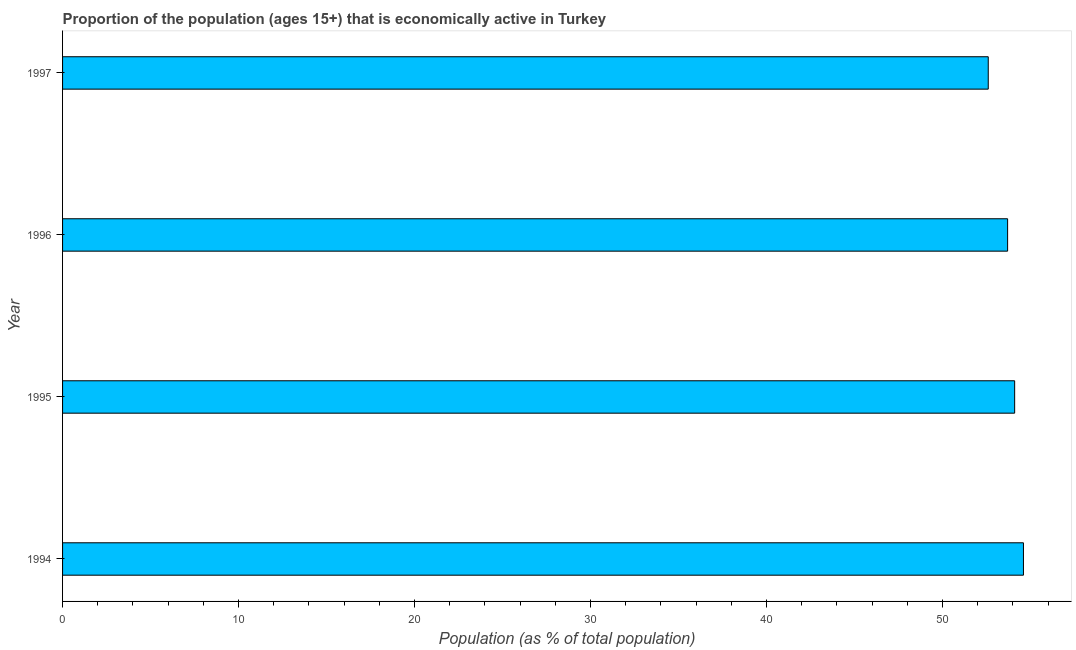What is the title of the graph?
Your answer should be compact. Proportion of the population (ages 15+) that is economically active in Turkey. What is the label or title of the X-axis?
Your response must be concise. Population (as % of total population). What is the label or title of the Y-axis?
Provide a succinct answer. Year. What is the percentage of economically active population in 1995?
Make the answer very short. 54.1. Across all years, what is the maximum percentage of economically active population?
Offer a very short reply. 54.6. Across all years, what is the minimum percentage of economically active population?
Make the answer very short. 52.6. In which year was the percentage of economically active population maximum?
Your answer should be very brief. 1994. What is the sum of the percentage of economically active population?
Give a very brief answer. 215. What is the average percentage of economically active population per year?
Offer a terse response. 53.75. What is the median percentage of economically active population?
Your answer should be compact. 53.9. Do a majority of the years between 1995 and 1996 (inclusive) have percentage of economically active population greater than 52 %?
Keep it short and to the point. Yes. What is the ratio of the percentage of economically active population in 1995 to that in 1997?
Provide a succinct answer. 1.03. Is the percentage of economically active population in 1994 less than that in 1997?
Your response must be concise. No. What is the difference between the highest and the second highest percentage of economically active population?
Offer a very short reply. 0.5. Is the sum of the percentage of economically active population in 1994 and 1996 greater than the maximum percentage of economically active population across all years?
Provide a succinct answer. Yes. What is the difference between the highest and the lowest percentage of economically active population?
Keep it short and to the point. 2. In how many years, is the percentage of economically active population greater than the average percentage of economically active population taken over all years?
Offer a terse response. 2. How many bars are there?
Offer a very short reply. 4. Are all the bars in the graph horizontal?
Give a very brief answer. Yes. Are the values on the major ticks of X-axis written in scientific E-notation?
Your answer should be very brief. No. What is the Population (as % of total population) of 1994?
Give a very brief answer. 54.6. What is the Population (as % of total population) of 1995?
Provide a short and direct response. 54.1. What is the Population (as % of total population) in 1996?
Your answer should be compact. 53.7. What is the Population (as % of total population) in 1997?
Offer a terse response. 52.6. What is the difference between the Population (as % of total population) in 1995 and 1996?
Make the answer very short. 0.4. What is the ratio of the Population (as % of total population) in 1994 to that in 1995?
Offer a very short reply. 1.01. What is the ratio of the Population (as % of total population) in 1994 to that in 1996?
Give a very brief answer. 1.02. What is the ratio of the Population (as % of total population) in 1994 to that in 1997?
Provide a short and direct response. 1.04. 